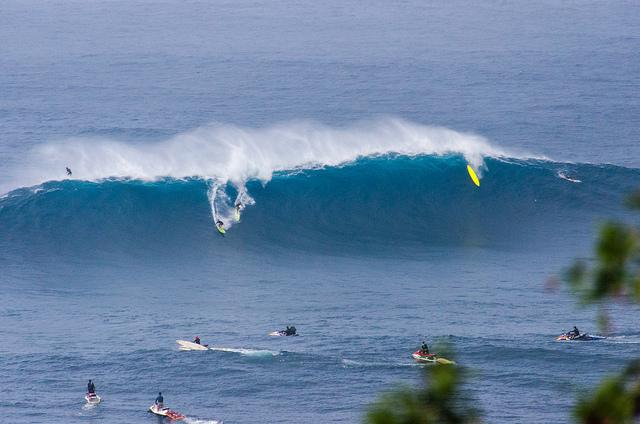How big is that wave?
Give a very brief answer. Big. How many people are in the ocean?
Keep it brief. 10. Is this a small wave?
Concise answer only. No. How many people are in this photo?
Quick response, please. 10. How many people are surfing?
Quick response, please. 5. Is there any boat in the picture?
Keep it brief. No. Is the ocean smooth?
Be succinct. No. 